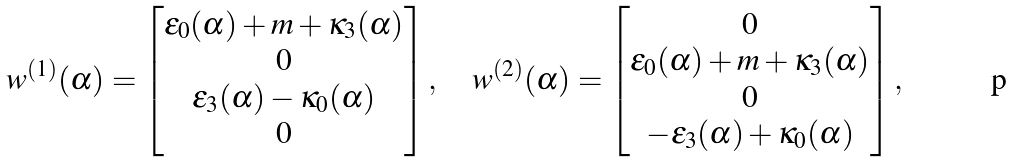<formula> <loc_0><loc_0><loc_500><loc_500>w ^ { ( 1 ) } ( \alpha ) = \begin{bmatrix} { \varepsilon } _ { 0 } ( \alpha ) + m + { \kappa } _ { 3 } ( \alpha ) \\ 0 \\ { \varepsilon } _ { 3 } ( \alpha ) - { \kappa } _ { 0 } ( \alpha ) \\ 0 \end{bmatrix} , \quad w ^ { ( 2 ) } ( \alpha ) = \begin{bmatrix} 0 \\ { \varepsilon } _ { 0 } ( \alpha ) + m + { \kappa } _ { 3 } ( \alpha ) \\ 0 \\ - { \varepsilon } _ { 3 } ( \alpha ) + { \kappa } _ { 0 } ( \alpha ) \end{bmatrix} ,</formula> 